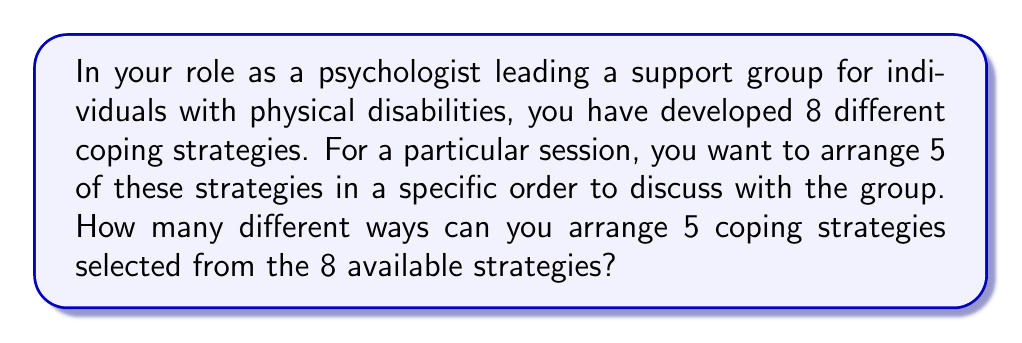Help me with this question. To solve this problem, we need to use the concept of permutations. Here's a step-by-step explanation:

1. First, we need to choose 5 strategies from the 8 available strategies. This is a combination problem.

2. Then, we need to arrange these 5 chosen strategies in different orders. This is a permutation problem.

3. The formula for this type of problem is:

   $$P(n,r) = \frac{n!}{(n-r)!}$$

   Where $n$ is the total number of items to choose from, and $r$ is the number of items being arranged.

4. In this case, $n = 8$ (total strategies) and $r = 5$ (strategies to be arranged).

5. Plugging these numbers into the formula:

   $$P(8,5) = \frac{8!}{(8-5)!} = \frac{8!}{3!}$$

6. Expanding this:
   
   $$\frac{8 \times 7 \times 6 \times 5 \times 4 \times 3!}{3!}$$

7. The $3!$ cancels out in the numerator and denominator:

   $$8 \times 7 \times 6 \times 5 \times 4 = 6720$$

Therefore, there are 6720 different ways to arrange 5 coping strategies selected from the 8 available strategies.
Answer: 6720 